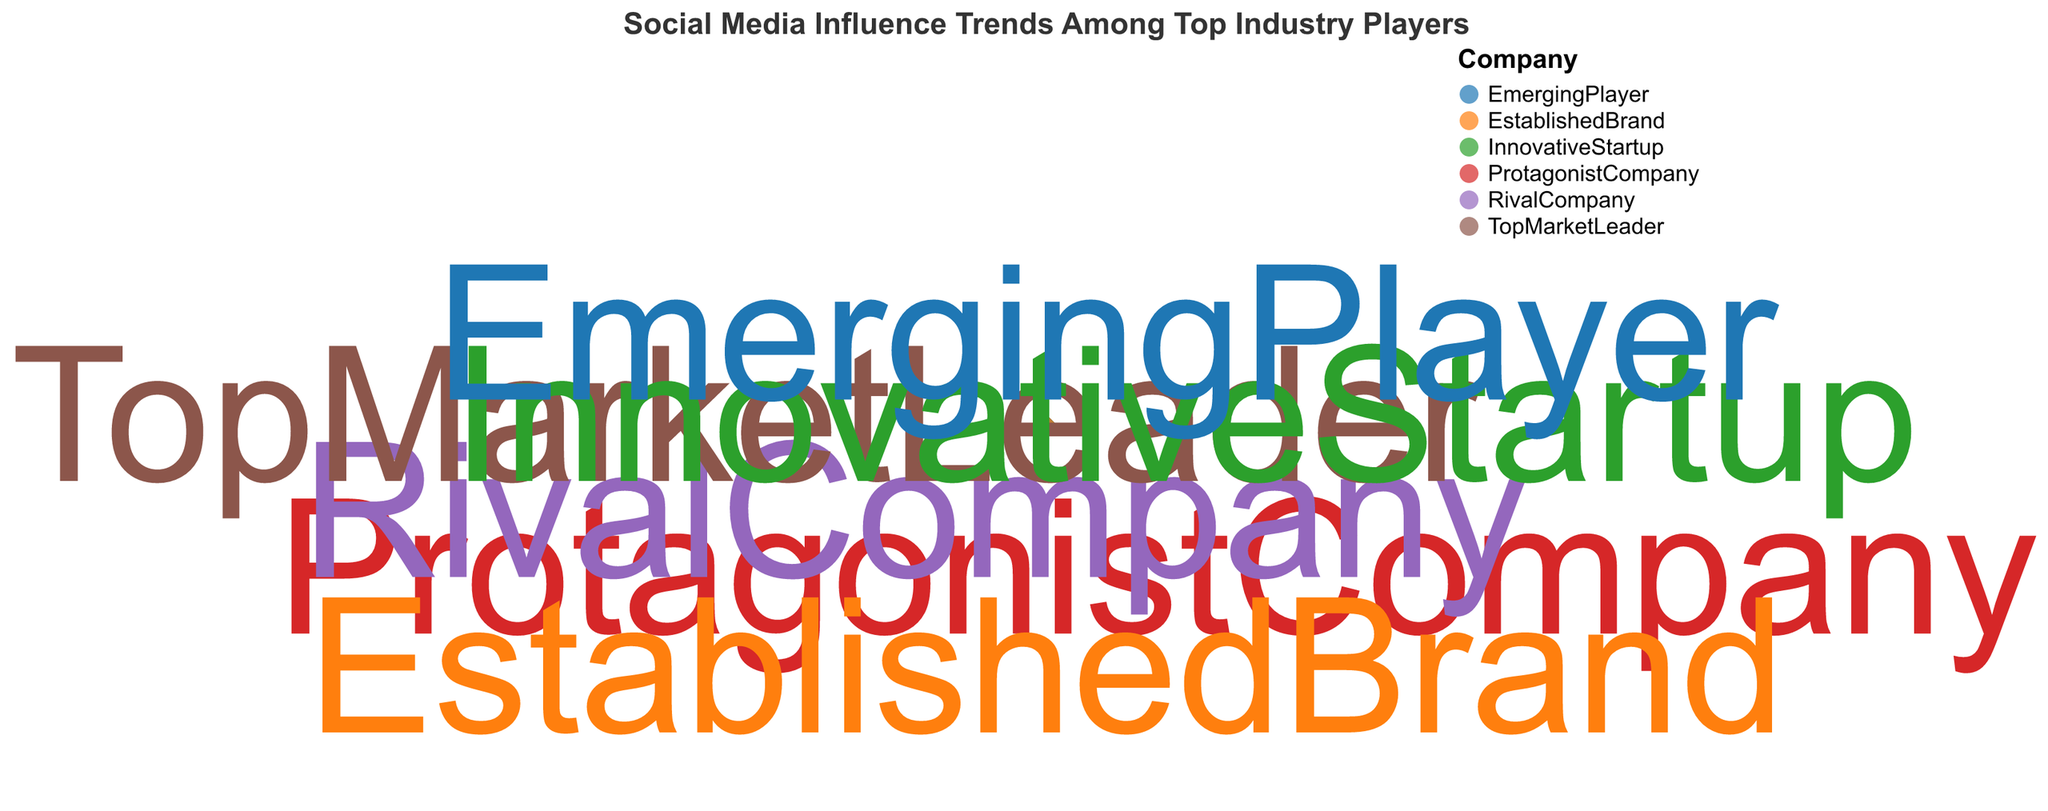How many companies are represented in the chart? The chart lists six companies as data points. Each data point represents one company.
Answer: 6 What is the title of the chart? The title is prominently displayed at the top of the chart, stating “Social Media Influence Trends Among Top Industry Players.”
Answer: Social Media Influence Trends Among Top Industry Players Which company has the highest Influence Score? By observing the spread and theta positions of the data points, TopMarketLeader is positioned the furthest along the theta axis, indicating the highest Influence Score of 95.
Answer: TopMarketLeader Which company has the highest Engagement Rate? TopMarketLeader is located farthest from the origin along the radius axis, which indicates it has the highest Engagement Rate of 6.1.
Answer: TopMarketLeader Compare the Influence Scores of ProtagonistCompany and RivalCompany. Which is higher and by how much? ProtagonistCompany has an Influence Score of 88, while RivalCompany has a higher Influence Score of 93. The difference is 93 - 88 = 5.
Answer: RivalCompany; 5 On average, how do the Engagement Rates of the top three companies compare to the bottom three? The top three companies based on Influence Score are TopMarketLeader (6.1), RivalCompany (5.0), and EstablishedBrand (5.7). Their average Engagement Rate is (6.1 + 5.0 + 5.7) / 3 = 5.6. The bottom three companies are ProtagonistCompany (5.2), InnovativeStartup (4.8), and EmergingPlayer (4.5). Their average Engagement Rate is (5.2 + 4.8 + 4.5) / 3 = 4.83. So, the top three companies have a greater average Engagement Rate.
Answer: Top three: 5.6; Bottom three: 4.83 Does any company have a higher Engagement Rate than EstablishedBrand? Comparing the Engagement Rates, TopMarketLeader has an Engagement Rate of 6.1, which is higher than EstablishedBrand's 5.7.
Answer: Yes, TopMarketLeader Which company is positioned closest to the center of the chart and what are its Influence Score and Engagement Rate? The company closest to the center would have the smallest Influence Score and Engagement Rate. EmergingPlayer is the closest, with an Influence Score of 82 and an Engagement Rate of 4.5.
Answer: EmergingPlayer; 82 and 4.5 Who has a better Engagement Rate, RivalCompany or ProtagonistCompany? Viewing the radial positions of RivalCompany and ProtagonistCompany, ProtagonistCompany has a higher Engagement Rate (5.2) compared to RivalCompany (5.0).
Answer: ProtagonistCompany What are the Influence Scores and Engagement Rates for the companies located on the extreme ends of the theta axis? On the extreme ends, we have TopMarketLeader with an Influence Score of 95 and an Engagement Rate of 6.1, and EmergingPlayer with an Influence Score of 82 and an Engagement Rate of 4.5.
Answer: TopMarketLeader: 95 and 6.1; EmergingPlayer: 82 and 4.5 